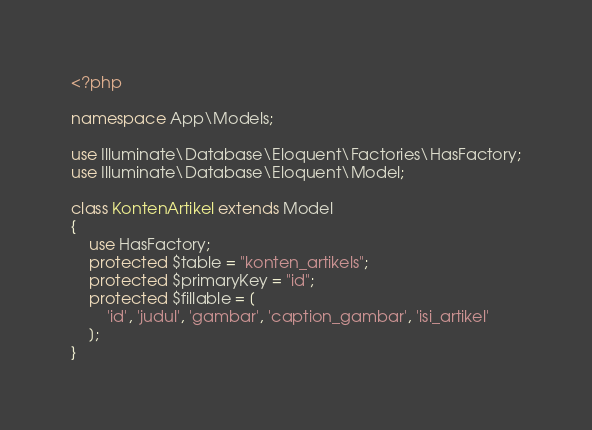Convert code to text. <code><loc_0><loc_0><loc_500><loc_500><_PHP_><?php

namespace App\Models;

use Illuminate\Database\Eloquent\Factories\HasFactory;
use Illuminate\Database\Eloquent\Model;

class KontenArtikel extends Model
{
    use HasFactory;
    protected $table = "konten_artikels";
    protected $primaryKey = "id";
    protected $fillable = [
        'id', 'judul', 'gambar', 'caption_gambar', 'isi_artikel'
    ];
}
</code> 